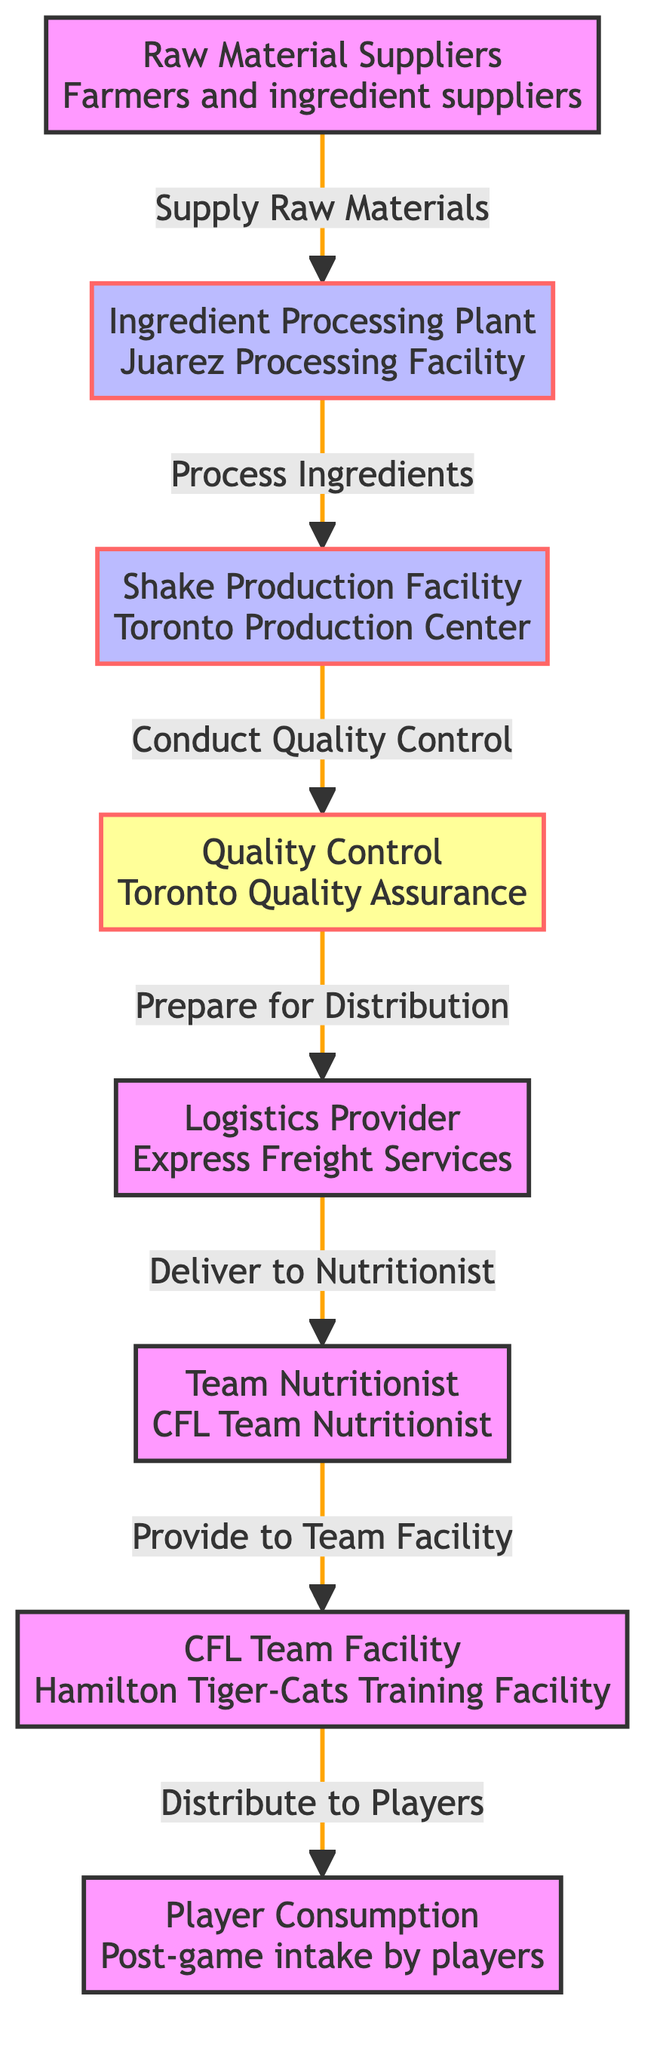What is the first step in the supply chain? The first step in the supply chain is represented by node 1, which is "Raw Material Suppliers." This indicates that the supply chain begins with farmers and ingredient suppliers who provide the raw materials needed for shake production.
Answer: Raw Material Suppliers How many nodes are in the diagram? The diagram contains a total of 8 nodes, which represent different stages in the supply chain from raw material suppliers to player consumption.
Answer: 8 Who conducts quality control in the process? Node 4 indicates the "Quality Control" stage, which is handled by the "Toronto Quality Assurance" team. This shows that this facility ensures the quality of the nutritional shakes before they are distributed.
Answer: Toronto Quality Assurance Which facility is responsible for producing the shakes? The "Shake Production Facility" is indicated by node 3, which is the "Toronto Production Center." This facility is where the actual production of the nutritional shakes takes place.
Answer: Toronto Production Center What is the final step of the supply chain? The last step in the supply chain is represented by node 8, which is "Player Consumption." This indicates that the final stage is when players consume the nutritional shakes after a game.
Answer: Player Consumption How does the logistics provider connect to the nutritionist? The logistics provider, denoted by node 5, delivers the shakes to the nutritionist, represented by node 6. This relationship shows that the logistics provider ensures the transportation of the shakes to the nutritionist for further handling.
Answer: Deliver to Nutritionist What is the role of the team nutritionist? Node 6 specifies that the "Team Nutritionist" is involved in the supply chain process. This indicates that their role is to receive the shakes from the logistics provider and prepare them for distribution to the training facility.
Answer: CFL Team Nutritionist Which step comes after ingredient processing? After "Ingredient Processing," represented by node 2, the next step is "Shake Production," indicated by node 3. This shows the flow from processing the ingredients to producing the actual shakes.
Answer: Shake Production 